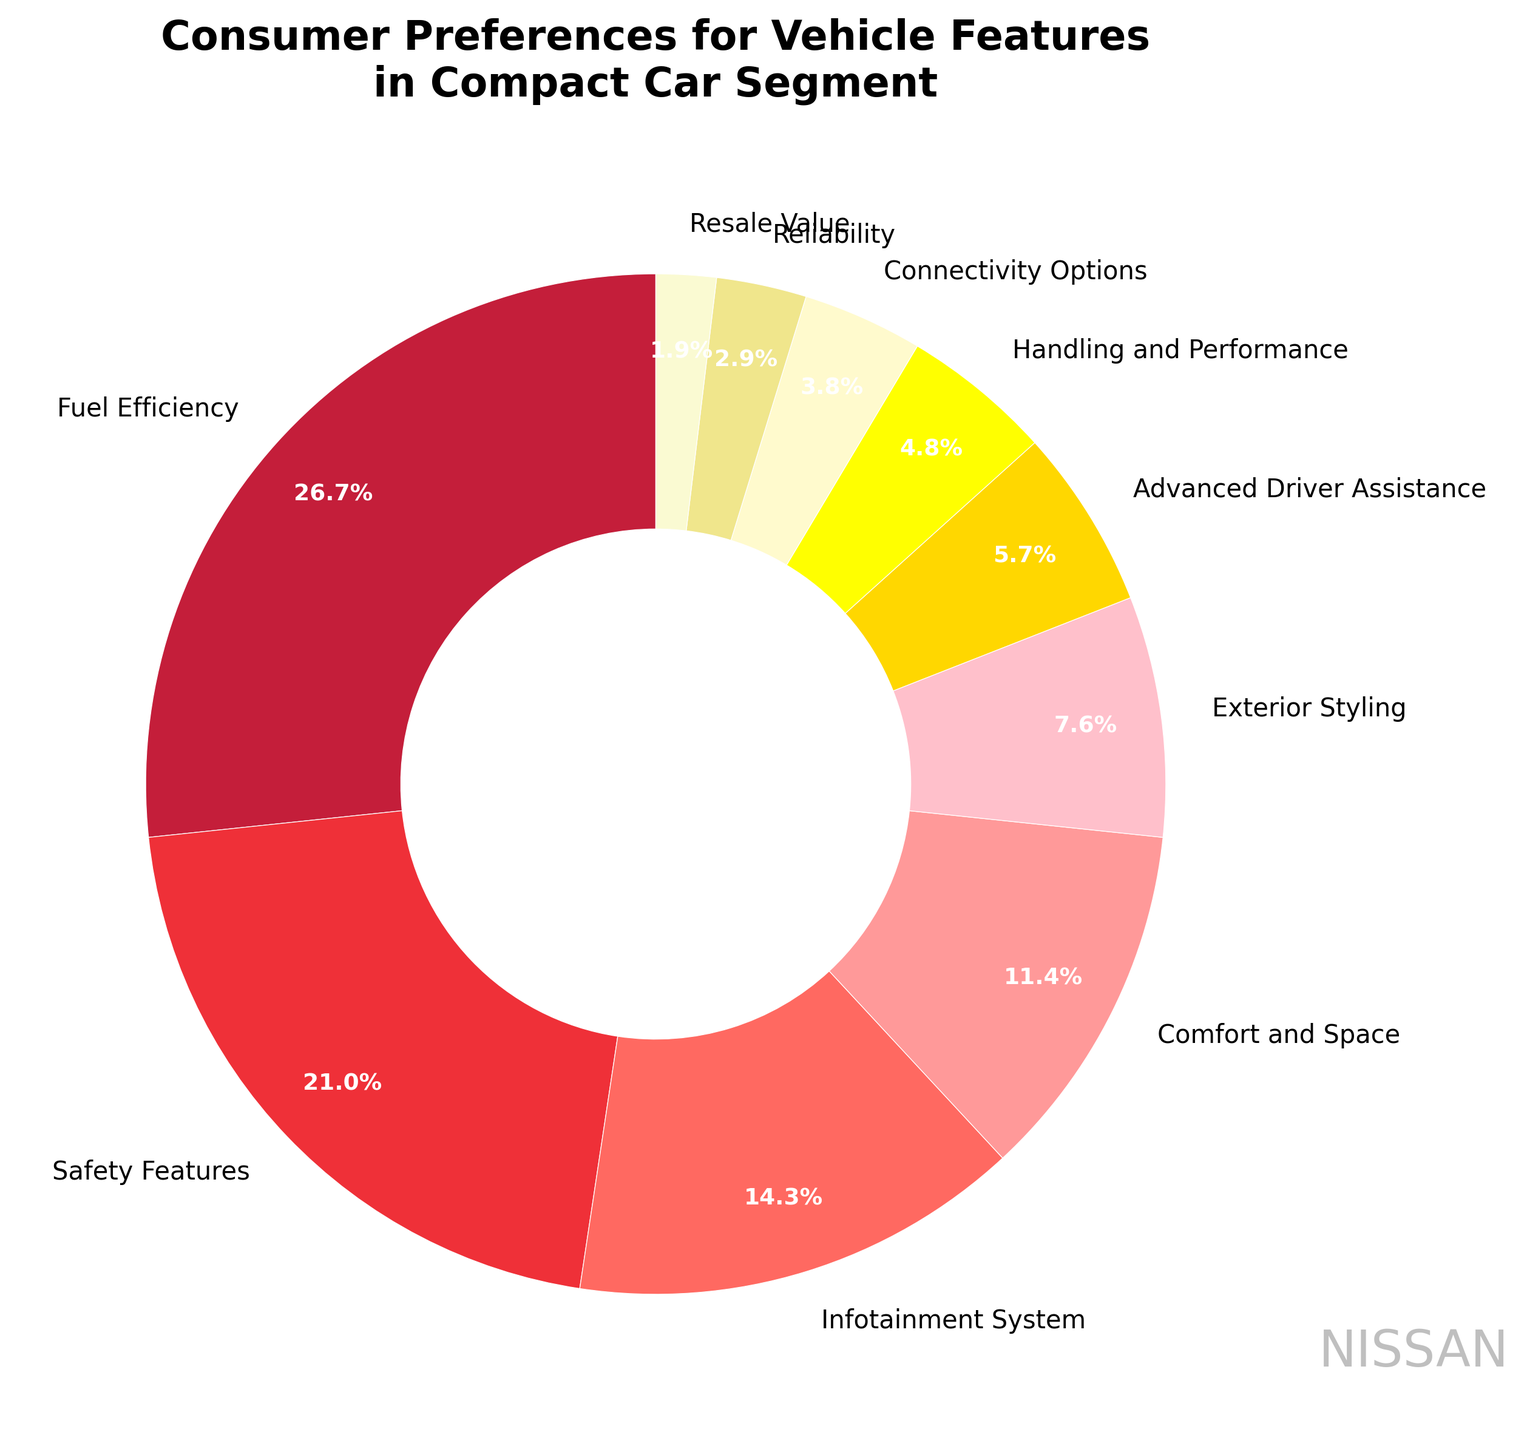What's the largest consumer preference feature in the compact car segment? The largest consumer preference feature can be identified visually by the largest wedge in the pie chart, which represents 'Fuel Efficiency' at 28%.
Answer: Fuel Efficiency Which feature has a higher preference: Advanced Driver Assistance or Safety Features? By comparing the sizes of the wedges in the pie chart, it's evident that 'Safety Features' at 22% has a higher preference than 'Advanced Driver Assistance' at 6%.
Answer: Safety Features What is the total percentage of consumers who prefer either Fuel Efficiency or Safety Features? Sum the percentages of 'Fuel Efficiency' (28%) and 'Safety Features' (22%): 28% + 22% = 50%.
Answer: 50% Rank the top three features based on consumer preference. By observing the pie chart, the top three features based on consumer preference are 'Fuel Efficiency' (28%), 'Safety Features' (22%), and 'Infotainment System' (15%) in descending order.
Answer: Fuel Efficiency, Safety Features, Infotainment System What is the combined preference for features related to technology (Infotainment System, Advanced Driver Assistance, and Connectivity Options)? Sum the percentages of 'Infotainment System' (15%), 'Advanced Driver Assistance' (6%), and 'Connectivity Options' (4%): 15% + 6% + 4% = 25%.
Answer: 25% Which feature is least preferred by consumers, and what is its percentage? The smallest wedge in the pie chart represents 'Resale Value' at 2%.
Answer: Resale Value, 2% By how much does the preference for Comfort and Space exceed the preference for Handling and Performance? Subtract the percentage of 'Handling and Performance' (5%) from 'Comfort and Space' (12%): 12% - 5% = 7%.
Answer: 7% What is the difference in preference percentage between Exterior Styling and Reliability? The percentage for 'Exterior Styling' is 8%, and for 'Reliability' is 3%. The difference is 8% - 3% = 5%.
Answer: 5% Which feature represents approximately one-fourth of consumer preferences in the compact car segment? The feature with a percentage closest to one-fourth (25%) is 'Fuel Efficiency,' which has a 28% preference.
Answer: Fuel Efficiency If you combine the preferences for Safety Features and Connectivity Options, does it exceed the preference for Fuel Efficiency? Sum the percentages of 'Safety Features' (22%) and 'Connectivity Options' (4%): 22% + 4% = 26%, which does not exceed 'Fuel Efficiency' at 28%.
Answer: No 